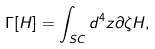Convert formula to latex. <formula><loc_0><loc_0><loc_500><loc_500>\Gamma [ H ] = \int _ { S C } d ^ { 4 } z \partial \zeta H ,</formula> 